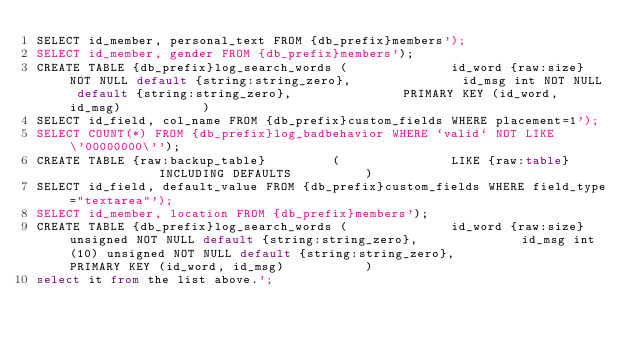<code> <loc_0><loc_0><loc_500><loc_500><_SQL_>SELECT id_member, personal_text FROM {db_prefix}members');
SELECT id_member, gender FROM {db_prefix}members');
CREATE TABLE {db_prefix}log_search_words (				id_word {raw:size} NOT NULL default {string:string_zero},				id_msg int NOT NULL default {string:string_zero},				PRIMARY KEY (id_word, id_msg)			)
SELECT id_field, col_name FROM {db_prefix}custom_fields WHERE placement=1');
SELECT COUNT(*) FROM {db_prefix}log_badbehavior WHERE `valid` NOT LIKE \'00000000\'');
CREATE TABLE {raw:backup_table}			(				LIKE {raw:table}				INCLUDING DEFAULTS			)
SELECT id_field, default_value FROM {db_prefix}custom_fields WHERE field_type="textarea"');
SELECT id_member, location FROM {db_prefix}members');
CREATE TABLE {db_prefix}log_search_words (				id_word {raw:size} unsigned NOT NULL default {string:string_zero},				id_msg int(10) unsigned NOT NULL default {string:string_zero},				PRIMARY KEY (id_word, id_msg)			)
select it from the list above.';
</code> 